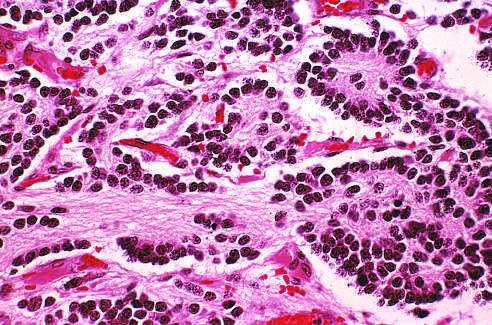what is this tumor composed of?
Answer the question using a single word or phrase. Small cells embedded in finely fibrillar matrix (neuropil) 